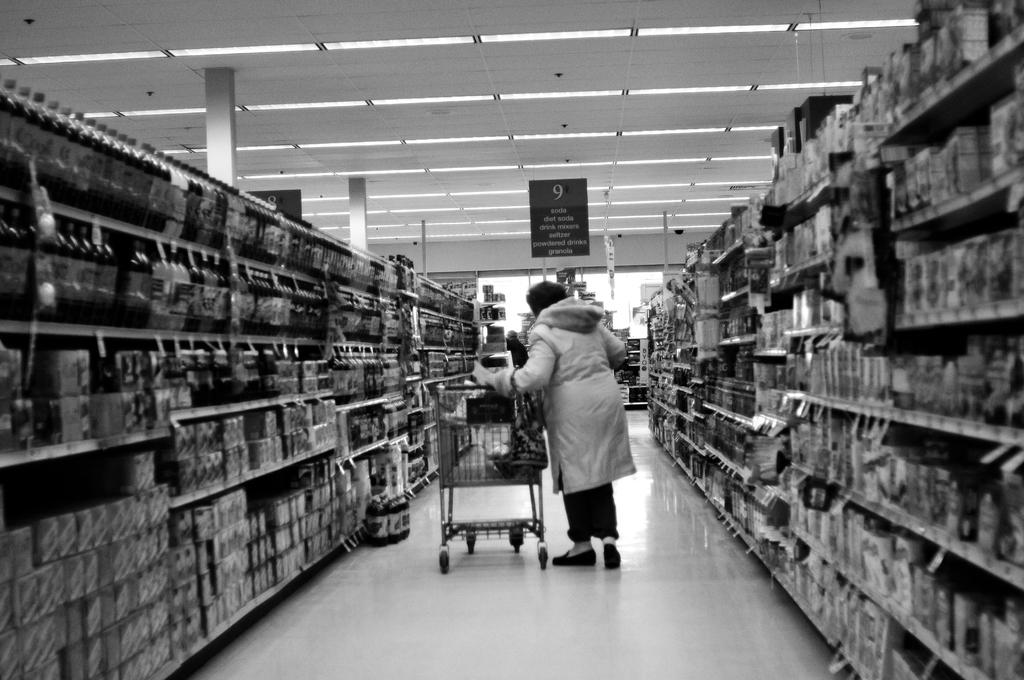<image>
Present a compact description of the photo's key features. A woman looking through aisle 9 of a grocery store 